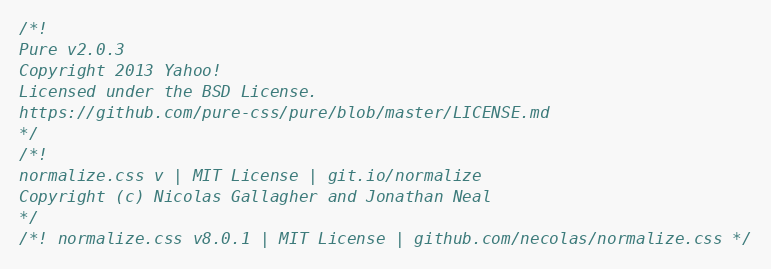<code> <loc_0><loc_0><loc_500><loc_500><_CSS_>/*!
Pure v2.0.3
Copyright 2013 Yahoo!
Licensed under the BSD License.
https://github.com/pure-css/pure/blob/master/LICENSE.md
*/
/*!
normalize.css v | MIT License | git.io/normalize
Copyright (c) Nicolas Gallagher and Jonathan Neal
*/
/*! normalize.css v8.0.1 | MIT License | github.com/necolas/normalize.css */</code> 